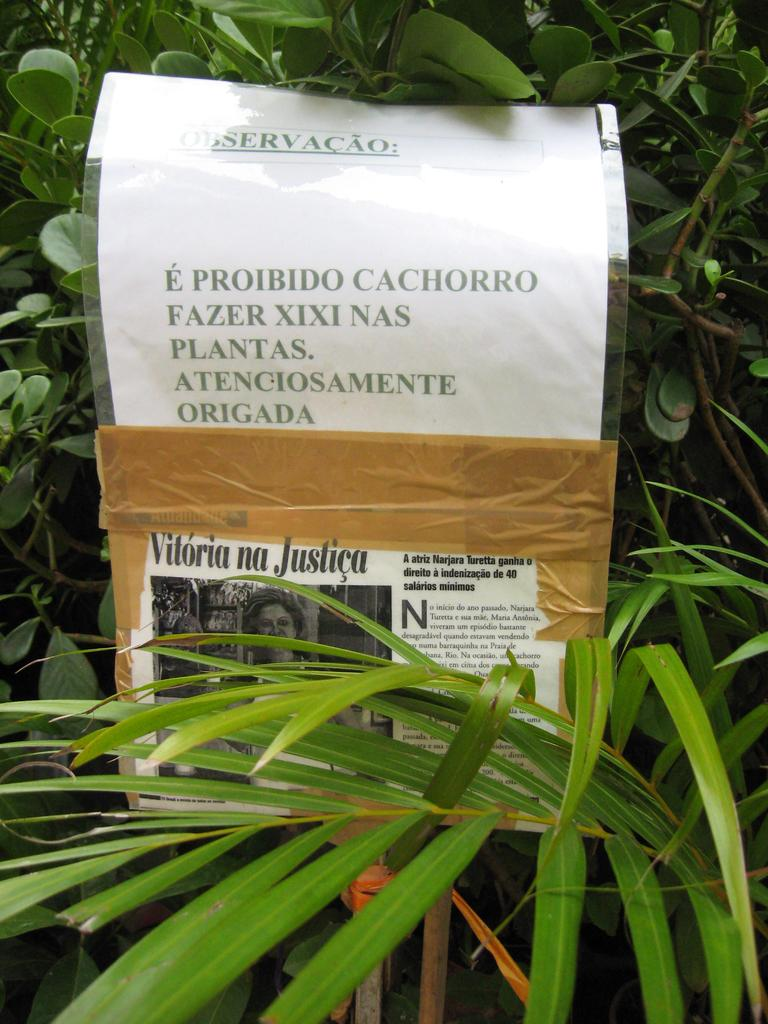What celestial bodies can be seen in the image? There are planets visible in the image. What is the paper in the image contained within? The paper is in a cover in the image. What is depicted on the paper? The paper contains a photo of a person. What additional information is present on the paper? There is writing on the paper. How does the fireman extinguish the rainstorm in the image? There is no fireman or rainstorm present in the image. 